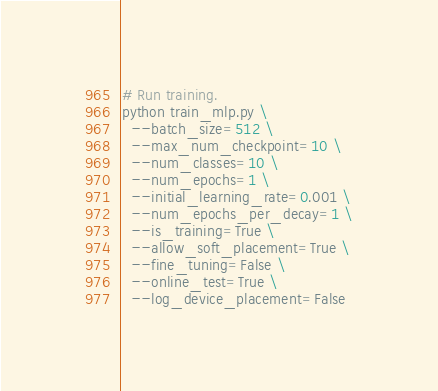Convert code to text. <code><loc_0><loc_0><loc_500><loc_500><_Bash_>
# Run training.
python train_mlp.py \
  --batch_size=512 \
  --max_num_checkpoint=10 \
  --num_classes=10 \
  --num_epochs=1 \
  --initial_learning_rate=0.001 \
  --num_epochs_per_decay=1 \
  --is_training=True \
  --allow_soft_placement=True \
  --fine_tuning=False \
  --online_test=True \
  --log_device_placement=False

</code> 